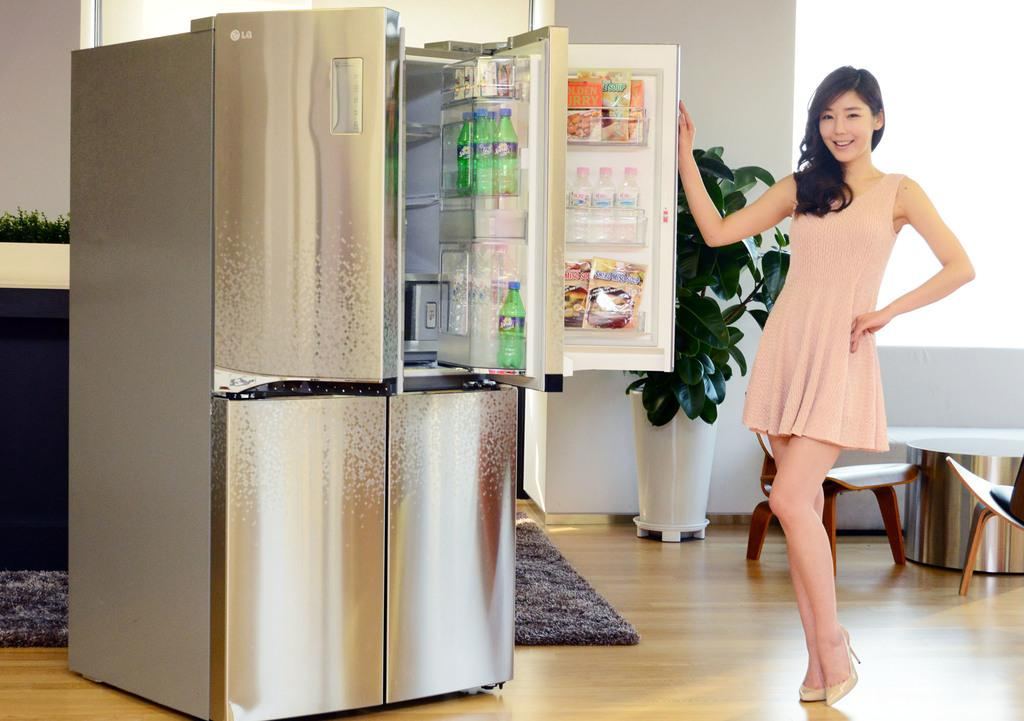<image>
Render a clear and concise summary of the photo. A woman in a salmon colored dress is holding a fridge door open with Golden Curry inside. 